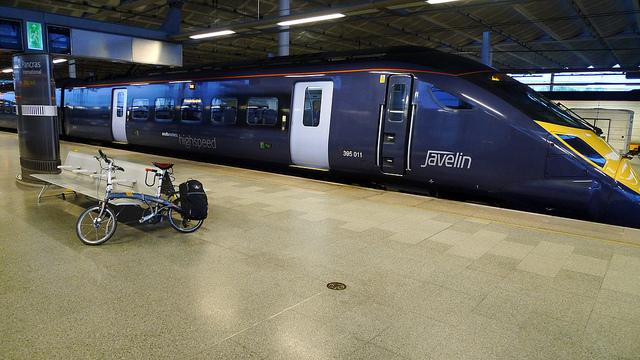How can one tell where the doors are on the train? white color 